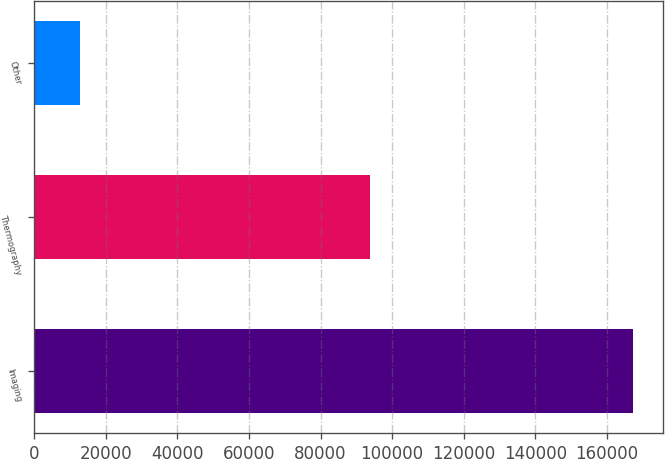<chart> <loc_0><loc_0><loc_500><loc_500><bar_chart><fcel>Imaging<fcel>Thermography<fcel>Other<nl><fcel>167246<fcel>93834<fcel>12816<nl></chart> 